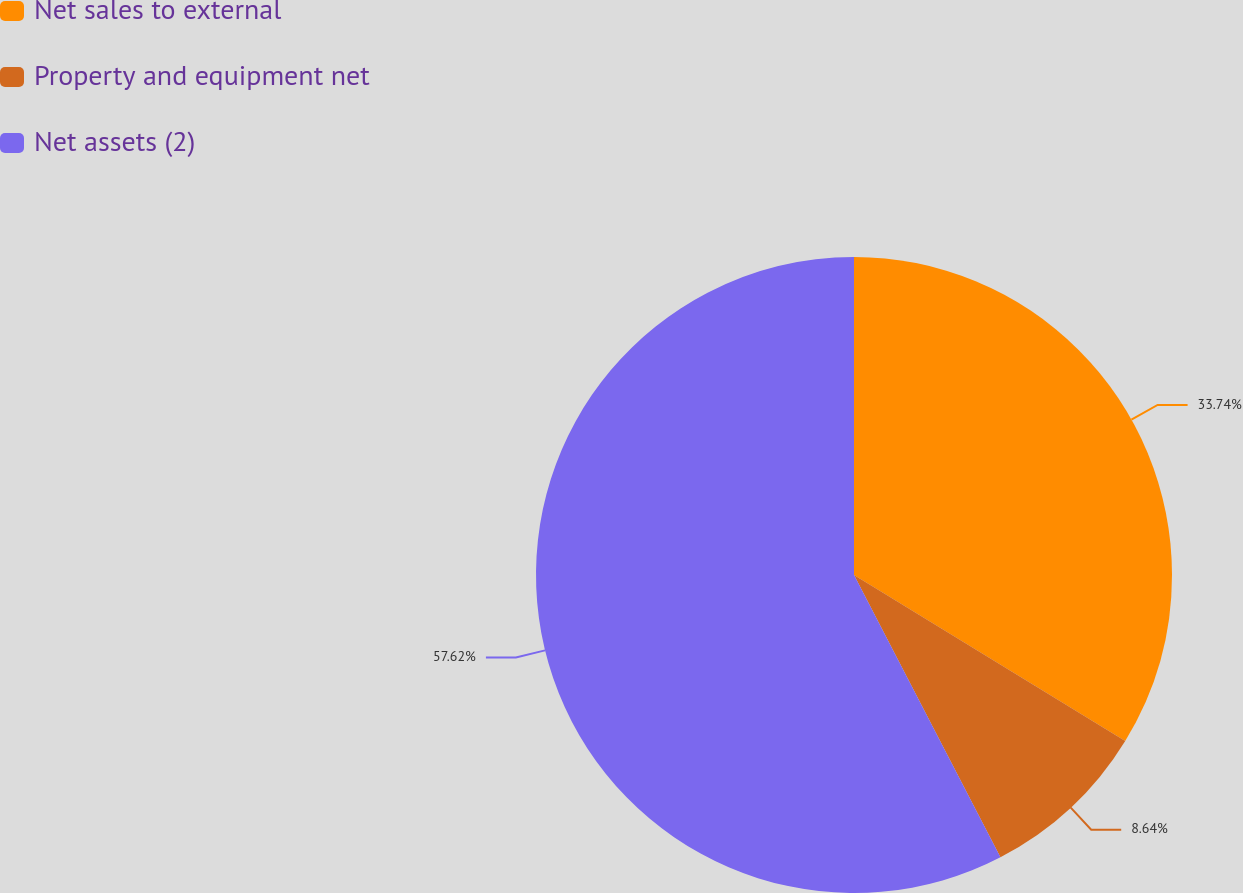Convert chart to OTSL. <chart><loc_0><loc_0><loc_500><loc_500><pie_chart><fcel>Net sales to external<fcel>Property and equipment net<fcel>Net assets (2)<nl><fcel>33.74%<fcel>8.64%<fcel>57.61%<nl></chart> 